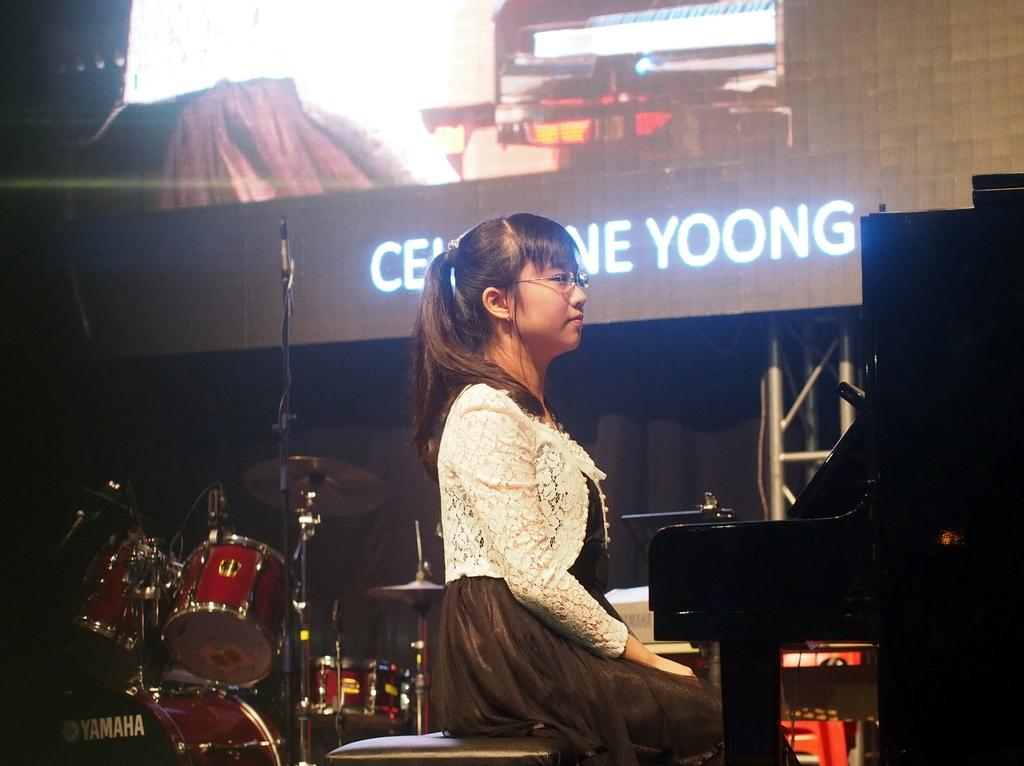What is the person in the image doing? The person is sitting in the image. What is the person wearing? The person is wearing a white and black color dress. What can be seen in the background of the image? There are musical instruments in the background of the image. What is the purpose of the screen visible in the image? The purpose of the screen is not specified in the facts, but it is visible in the image. What type of brick is being used to build the border around the person in the image? There is no brick or border present in the image; it features a person sitting and musical instruments in the background. 